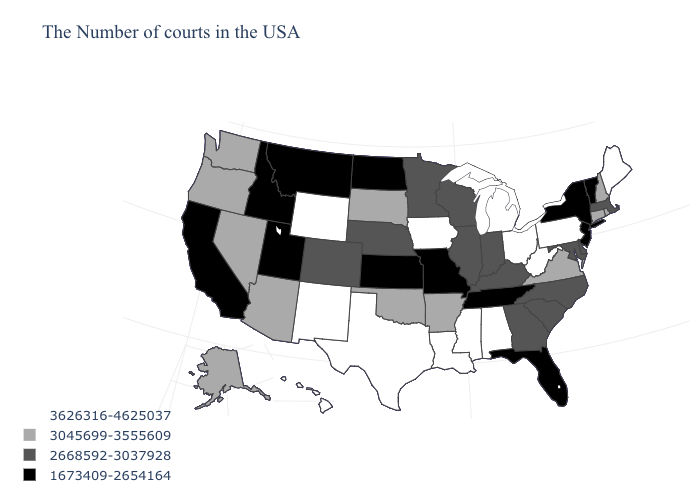What is the value of Mississippi?
Write a very short answer. 3626316-4625037. What is the value of Vermont?
Short answer required. 1673409-2654164. What is the highest value in states that border Florida?
Answer briefly. 3626316-4625037. What is the value of Idaho?
Be succinct. 1673409-2654164. Which states have the lowest value in the USA?
Short answer required. Vermont, New York, New Jersey, Florida, Tennessee, Missouri, Kansas, North Dakota, Utah, Montana, Idaho, California. Name the states that have a value in the range 3045699-3555609?
Write a very short answer. Rhode Island, New Hampshire, Connecticut, Virginia, Arkansas, Oklahoma, South Dakota, Arizona, Nevada, Washington, Oregon, Alaska. Does Kentucky have the lowest value in the South?
Give a very brief answer. No. Does Hawaii have a higher value than Wyoming?
Concise answer only. No. Is the legend a continuous bar?
Quick response, please. No. Name the states that have a value in the range 3045699-3555609?
Short answer required. Rhode Island, New Hampshire, Connecticut, Virginia, Arkansas, Oklahoma, South Dakota, Arizona, Nevada, Washington, Oregon, Alaska. Does North Carolina have the lowest value in the USA?
Quick response, please. No. What is the value of West Virginia?
Give a very brief answer. 3626316-4625037. Name the states that have a value in the range 3626316-4625037?
Answer briefly. Maine, Pennsylvania, West Virginia, Ohio, Michigan, Alabama, Mississippi, Louisiana, Iowa, Texas, Wyoming, New Mexico, Hawaii. Name the states that have a value in the range 3626316-4625037?
Give a very brief answer. Maine, Pennsylvania, West Virginia, Ohio, Michigan, Alabama, Mississippi, Louisiana, Iowa, Texas, Wyoming, New Mexico, Hawaii. Name the states that have a value in the range 2668592-3037928?
Quick response, please. Massachusetts, Delaware, Maryland, North Carolina, South Carolina, Georgia, Kentucky, Indiana, Wisconsin, Illinois, Minnesota, Nebraska, Colorado. 